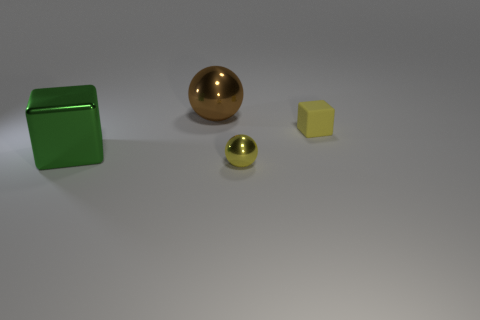The other tiny matte thing that is the same shape as the green object is what color?
Provide a short and direct response. Yellow. Is the number of small gray things the same as the number of yellow rubber blocks?
Your answer should be very brief. No. How many matte things are the same shape as the large brown metal thing?
Ensure brevity in your answer.  0. What material is the small ball that is the same color as the matte cube?
Provide a succinct answer. Metal. What number of blue rubber balls are there?
Your answer should be compact. 0. Are there any small yellow objects made of the same material as the brown object?
Ensure brevity in your answer.  Yes. There is a rubber cube that is the same color as the small sphere; what is its size?
Give a very brief answer. Small. There is a object that is behind the tiny rubber cube; is its size the same as the thing that is in front of the large block?
Make the answer very short. No. What is the size of the metal ball that is to the right of the big brown ball?
Your answer should be very brief. Small. Are there any rubber cubes of the same color as the small shiny ball?
Provide a short and direct response. Yes. 